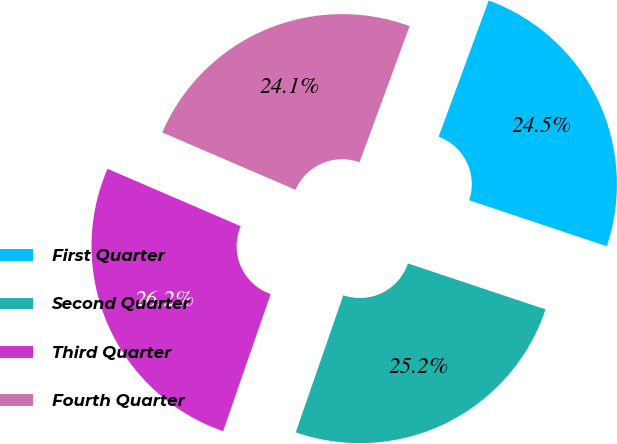Convert chart. <chart><loc_0><loc_0><loc_500><loc_500><pie_chart><fcel>First Quarter<fcel>Second Quarter<fcel>Third Quarter<fcel>Fourth Quarter<nl><fcel>24.52%<fcel>25.18%<fcel>26.16%<fcel>24.13%<nl></chart> 